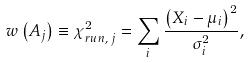<formula> <loc_0><loc_0><loc_500><loc_500>w \left ( A _ { j } \right ) \equiv \chi _ { r u n , \, j } ^ { 2 } = \sum _ { i } \frac { \left ( X _ { i } - \mu _ { i } \right ) ^ { 2 } } { \sigma _ { i } ^ { 2 } } ,</formula> 